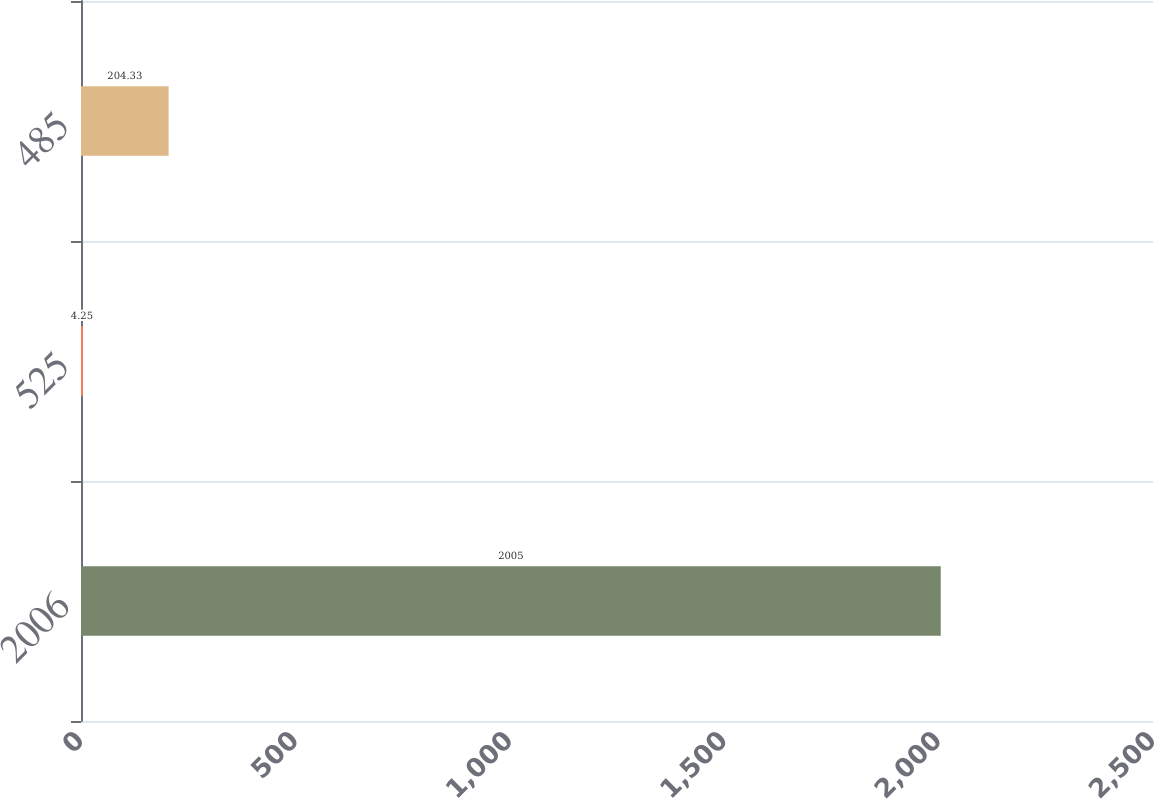Convert chart to OTSL. <chart><loc_0><loc_0><loc_500><loc_500><bar_chart><fcel>2006<fcel>525<fcel>485<nl><fcel>2005<fcel>4.25<fcel>204.33<nl></chart> 